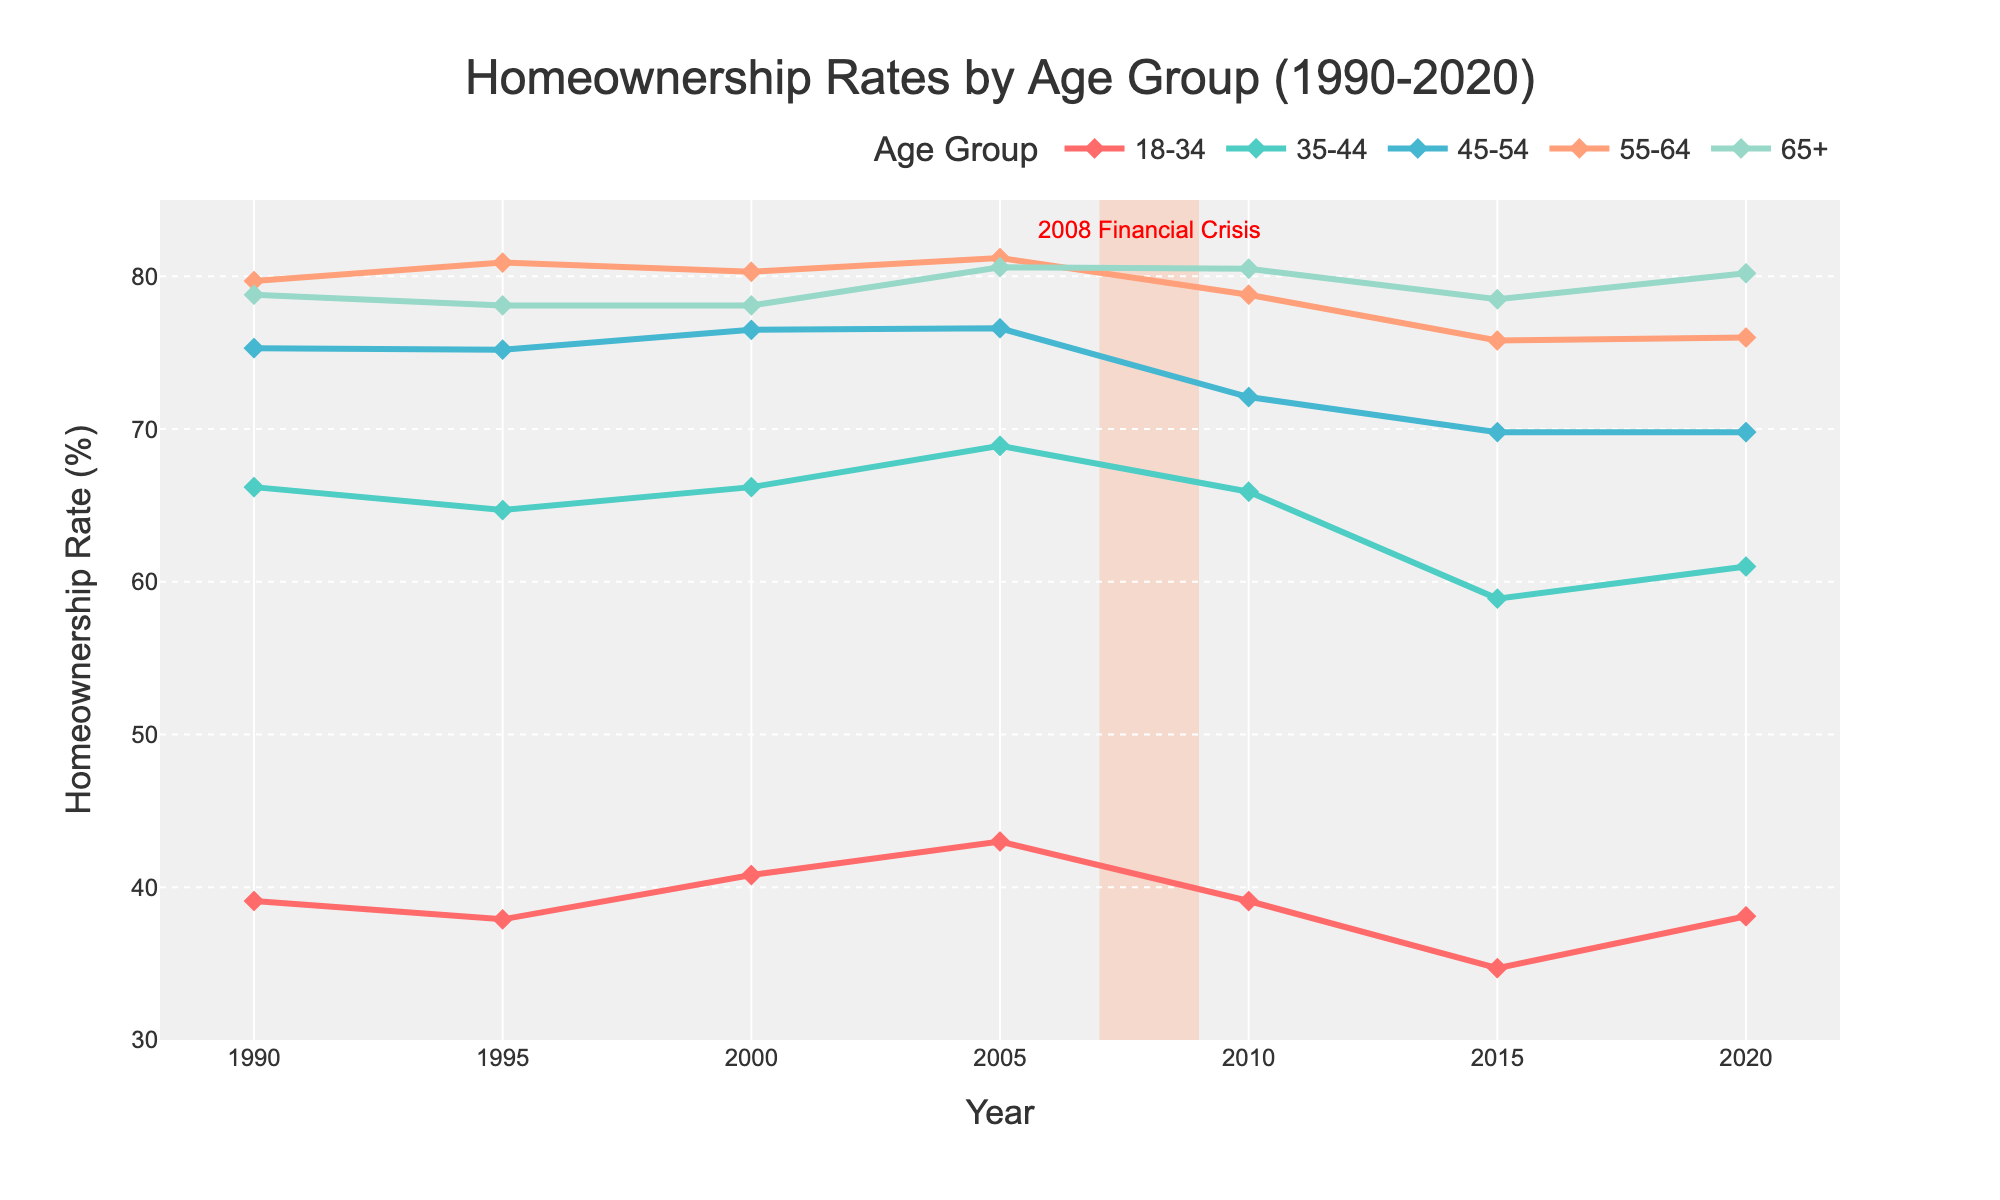Which age group had the highest homeownership rate in 2020? Identify the data point for each age group in 2020 and compare the values. The age group 65+ had a homeownership rate of 80.2%, which is the highest compared to the other groups.
Answer: 65+ How did the homeownership rate for the 18-34 age group change between 1990 and 2020? Look at the homeownership rates for the 18-34 age group in 1990 and 2020. In 1990, the rate was 39.1%, and in 2020, it was 38.1%. The difference is 39.1 - 38.1 = 1%, indicating a slight decrease.
Answer: Decreased by 1% Which age group experienced the steepest decline in homeownership rates during the 2008 Financial Crisis (2007-2009)? Examine the change in homeownership rates for each age group from 2007 to 2009. The 35-44 age group saw a drop from 68.9% to 65.9%, a decline of 3%, which is the largest drop compared to other age groups.
Answer: 35-44 What is the difference in homeownership rates between the oldest (65+) and the youngest (18-34) age groups in 2020? Subtract the homeownership rate of the youngest group (18-34, which is 38.1%) from the oldest group (65+, which is 80.2%) in 2020. The difference is 80.2 - 38.1 = 42.1%.
Answer: 42.1% Which age group showed the least change in homeownership rates from 1990 to 2020? Calculate the difference in the homeownership rates for each age group between 1990 and 2020. For 65+, the difference is 80.2 - 78.8 = 1.4%, which is the smallest change compared to other age groups.
Answer: 65+ Has the homeownership rate for the 45-54 age group in 2020 returned to or exceeded its 1995 level? Compare the rates of the 45-54 age group in 1995 and 2020. In 1995, the rate was 75.2%, and in 2020, it was 69.8%, which indicates that the rate has not returned to the 1995 level.
Answer: No In 2005, which age group had the second-highest homeownership rate? Identify the homeownership rates for all age groups in 2005 and compare them. The 55-64 age group had the highest rate at 81.2%, and the 45-54 age group had the second-highest rate at 76.6%.
Answer: 45-54 What's the average homeownership rate for the 35-44 age group over the entire period (1990-2020)? Sum up the homeownership rates for the 35-44 age group over the given years (66.2, 64.7, 66.2, 68.9, 65.9, 58.9, 61.0) and divide by the number of years (7). The average rate is (66.2 + 64.7 + 66.2 + 68.9 + 65.9 + 58.9 + 61.0) / 7 = 64.54%.
Answer: 64.54% During which period did the homeownership rate for the 55-64 age group experience the largest single-year drop? Look at the year-to-year differences for the 55-64 age group. The largest one-year drop occurred from 2005 to 2010, where the rate dropped from 81.2% to 78.8%, a decline of 2.4%.
Answer: 2005-2010 